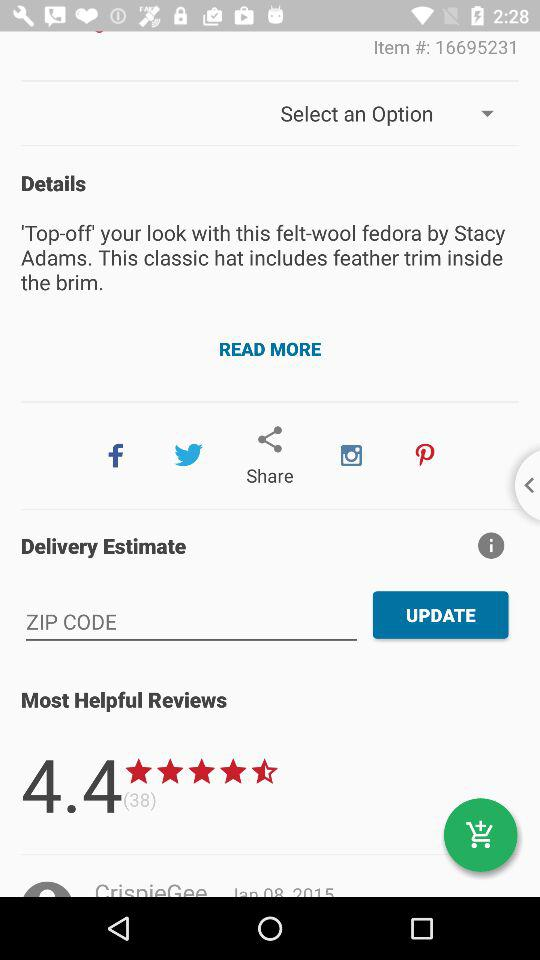Through which applications can we share? You can share through "Facebook", "Twitter", "Instagram" and "Pinterest". 